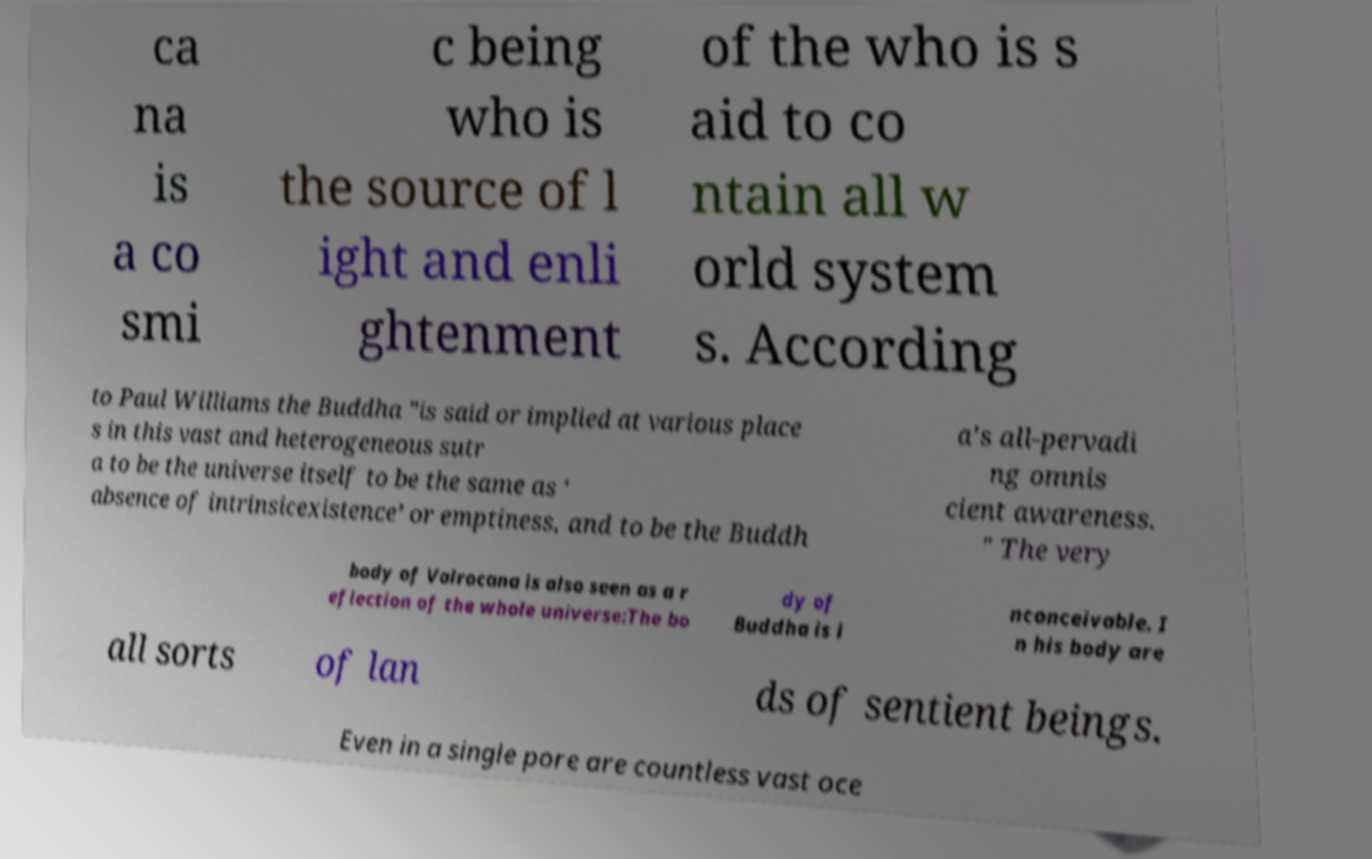Could you extract and type out the text from this image? ca na is a co smi c being who is the source of l ight and enli ghtenment of the who is s aid to co ntain all w orld system s. According to Paul Williams the Buddha "is said or implied at various place s in this vast and heterogeneous sutr a to be the universe itself to be the same as ‘ absence of intrinsicexistence’ or emptiness, and to be the Buddh a's all-pervadi ng omnis cient awareness. " The very body of Vairocana is also seen as a r eflection of the whole universe:The bo dy of Buddha is i nconceivable. I n his body are all sorts of lan ds of sentient beings. Even in a single pore are countless vast oce 